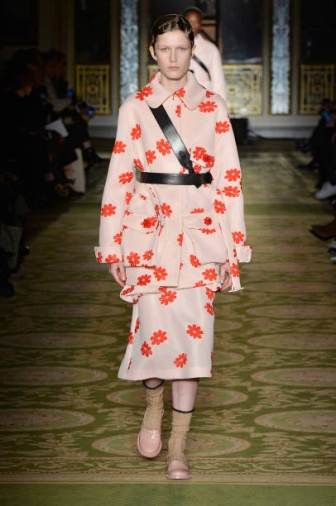What do you think inspired the design of the model's outfit? The design of the model's outfit appears to be inspired by a combination of bold and whimsical elements. The vibrant pink base adorned with striking red flower patterns might draw inspiration from natural floral beauty, aiming to bring a sense of joy and vibrancy. The black sash adds a touch of contrast and modernity, suggesting an influence of contemporary fashion aesthetics. The unexpected combination of pink socks with beige heels indicates a playful approach, celebrating creativity and individuality. Imagine a story where this fashion show is set in a futuristic world. How would everything look? In a futuristic world, this fashion show would be an ultra-modern blend of technology and style. The opulent room would be transformed into a high-tech environment, with holographic gold details and a virtual green runway that changes colors and patterns seamlessly. The audience could be watching from both physical seats and via virtual reality headsets, allowing a global audience to experience the show in real-time. The model’s outfit, while retaining its vibrant essence, might feature LED-embedded flowers that light up and change colors in sync with the runway. The pink socks could have smart fabrics that adapt to the wearer’s comfort, while the heels might be sleek, zero-gravity footwear giving the model an almost floating appearance. The atmosphere would be one of futuristic elegance, blending the charm of traditional fashion shows with cutting-edge technology. 